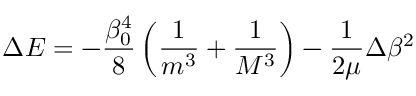Convert formula to latex. <formula><loc_0><loc_0><loc_500><loc_500>\Delta E = - \frac { \beta _ { 0 } ^ { 4 } } 8 \left ( \frac { 1 } m ^ { 3 } } + \frac { 1 } M ^ { 3 } } \right ) - \frac { 1 } 2 \mu } \Delta \beta ^ { 2 }</formula> 